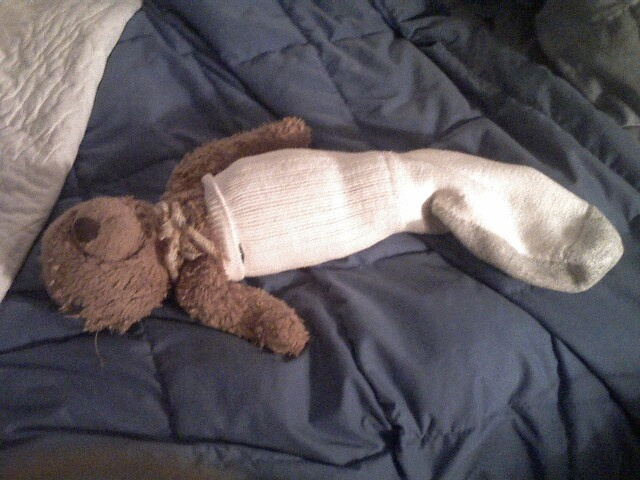Describe the objects in this image and their specific colors. I can see bed in gray, black, lightgray, and darkgray tones and teddy bear in darkgray, brown, gray, and maroon tones in this image. 